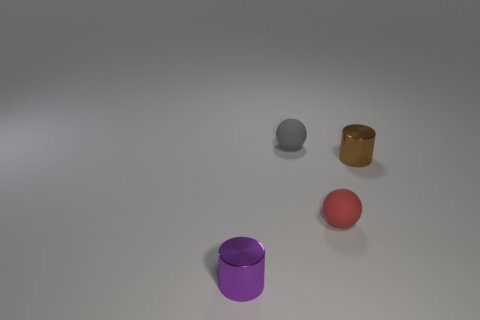Add 3 small purple metal cubes. How many objects exist? 7 Add 3 big yellow metal cylinders. How many big yellow metal cylinders exist? 3 Subtract 1 red spheres. How many objects are left? 3 Subtract all metal things. Subtract all purple metal cylinders. How many objects are left? 1 Add 2 red things. How many red things are left? 3 